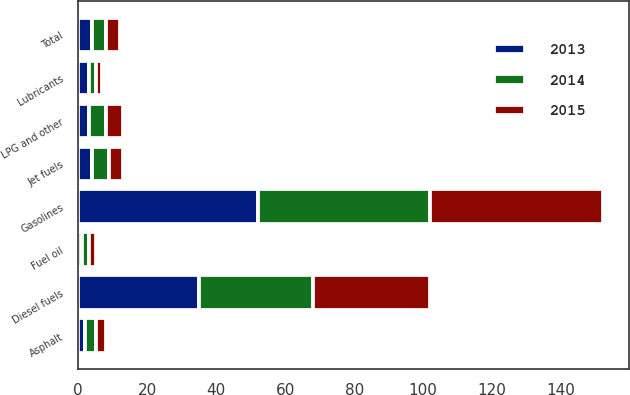<chart> <loc_0><loc_0><loc_500><loc_500><stacked_bar_chart><ecel><fcel>Gasolines<fcel>Diesel fuels<fcel>Jet fuels<fcel>Fuel oil<fcel>Asphalt<fcel>Lubricants<fcel>LPG and other<fcel>Total<nl><fcel>2013<fcel>52<fcel>35<fcel>4<fcel>1<fcel>2<fcel>3<fcel>3<fcel>4<nl><fcel>2015<fcel>50<fcel>34<fcel>4<fcel>2<fcel>3<fcel>2<fcel>5<fcel>4<nl><fcel>2014<fcel>50<fcel>33<fcel>5<fcel>2<fcel>3<fcel>2<fcel>5<fcel>4<nl></chart> 